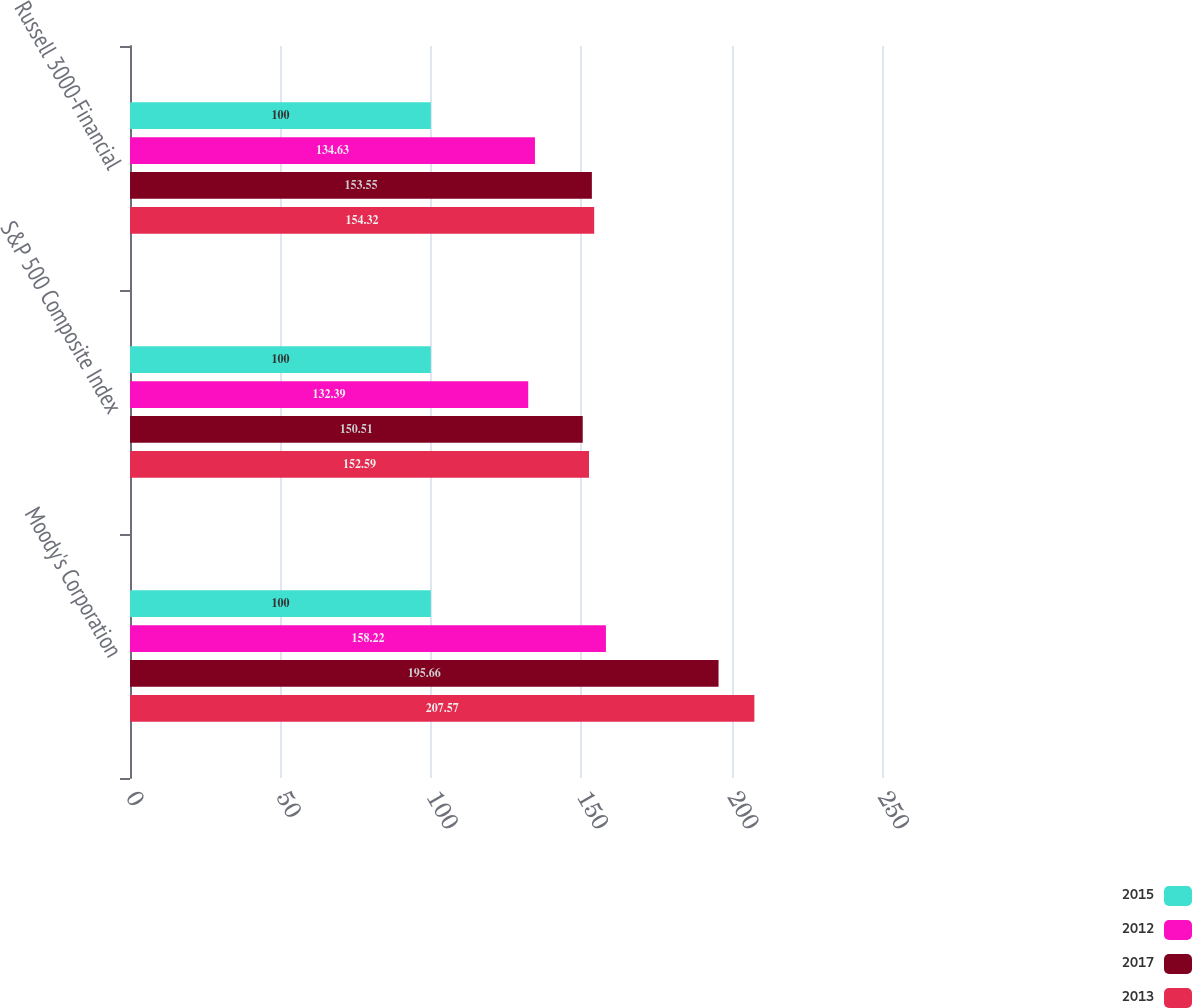<chart> <loc_0><loc_0><loc_500><loc_500><stacked_bar_chart><ecel><fcel>Moody's Corporation<fcel>S&P 500 Composite Index<fcel>Russell 3000-Financial<nl><fcel>2015<fcel>100<fcel>100<fcel>100<nl><fcel>2012<fcel>158.22<fcel>132.39<fcel>134.63<nl><fcel>2017<fcel>195.66<fcel>150.51<fcel>153.55<nl><fcel>2013<fcel>207.57<fcel>152.59<fcel>154.32<nl></chart> 